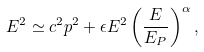<formula> <loc_0><loc_0><loc_500><loc_500>E ^ { 2 } \simeq c ^ { 2 } p ^ { 2 } + \epsilon E ^ { 2 } \left ( \frac { E } { E _ { P } } \right ) ^ { \alpha } ,</formula> 